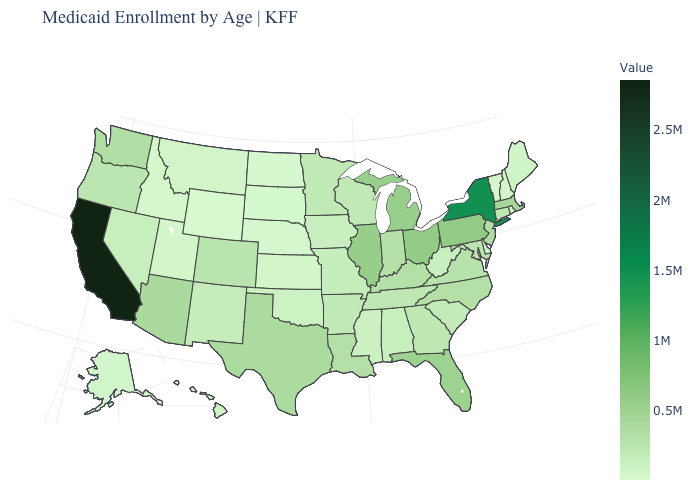Which states have the highest value in the USA?
Keep it brief. California. Does Wyoming have the lowest value in the USA?
Give a very brief answer. Yes. Which states hav the highest value in the MidWest?
Write a very short answer. Ohio. Does Maine have a higher value than New York?
Give a very brief answer. No. 